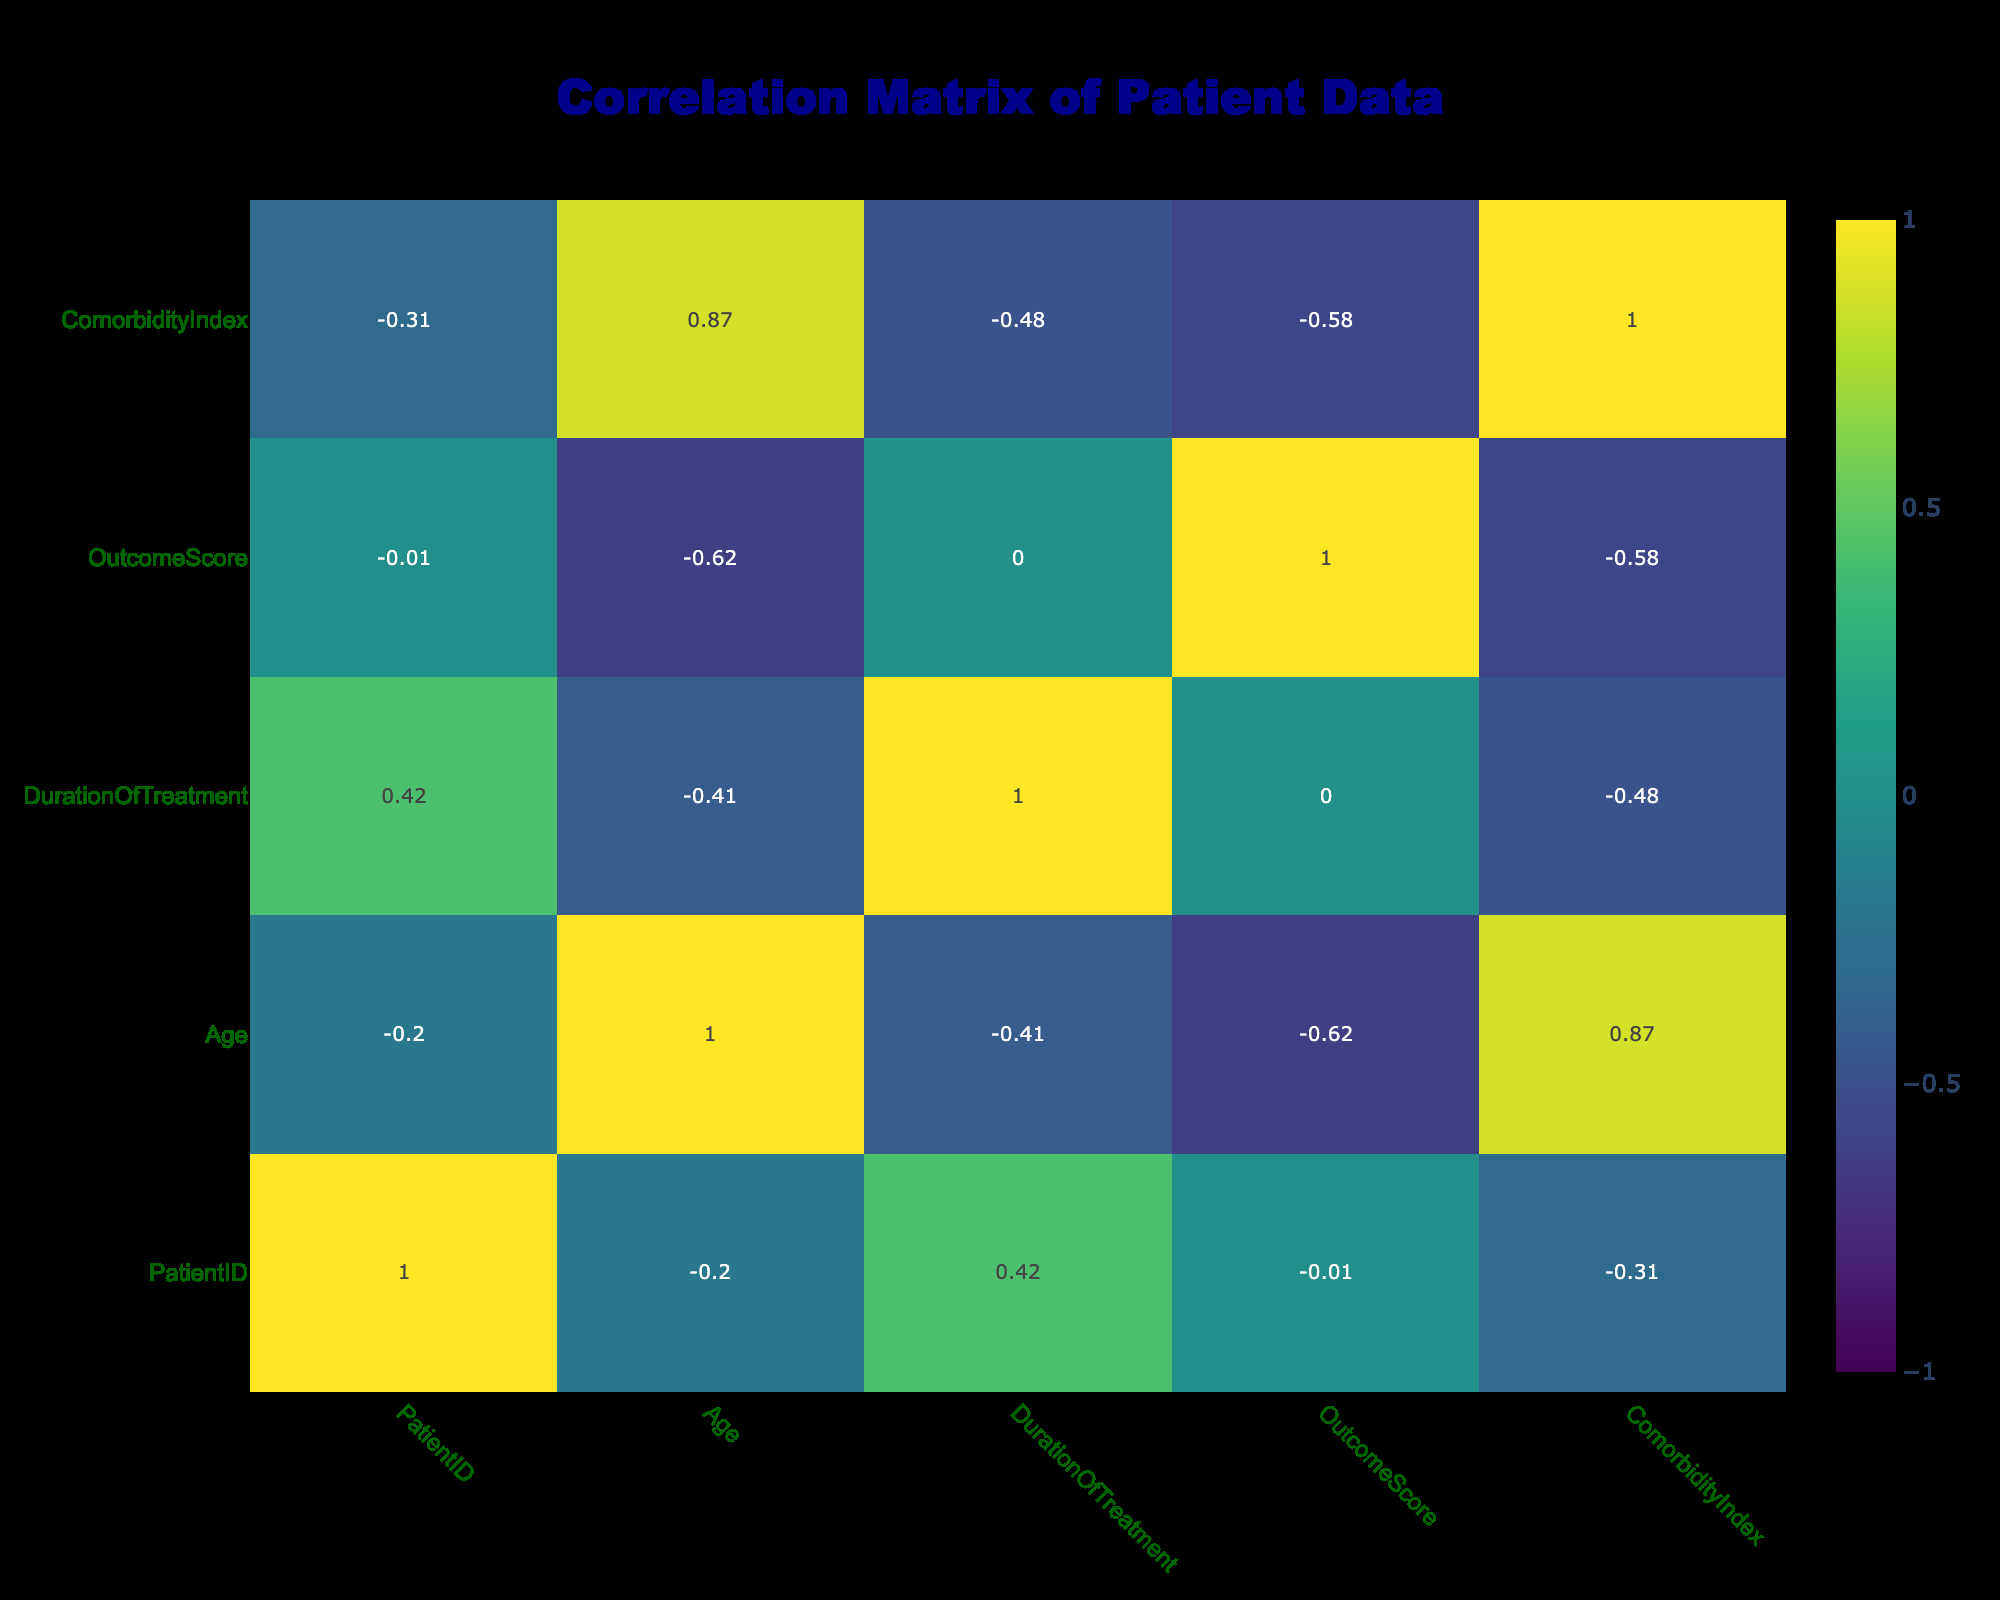What is the correlation between Outcome Score and Duration of Treatment? The correlation value between Outcome Score and Duration of Treatment can be directly observed in the correlation matrix at the intersecting row and column. This value indicates how strongly these two variables are related.
Answer: The correlation is approximately 0.15 Is there a higher average Outcome Score for patients who underwent Surgery compared to those who received Radiation treatment? To find the average Outcome Score, we first identify the Outcome Scores for both Surgery (95, 90, 93) and Radiation (75, 70, 80). Calculating these gives us 92.67 for Surgery and 75 for Radiation. Comparing these averages shows that Surgery has a higher Outcome Score.
Answer: Yes What is the average Comorbidity Index for all female patients? The Comorbidity Index values for female patients are found in the data (3, 4, 5). Summing these gives 12, and dividing by the total female patients (3) yields an average of 4.
Answer: The average is 4 Is there a correlation of 1 between Treatment Type and Outcome Score? Correlation of 1 indicates a perfect positive relationship. Observing the correlation matrix will show that the correlation between Treatment Type (categorical) and Outcome Score does not reach 1, as treatment types vary and do not dictate outcome scores perfectly.
Answer: No What is the difference in average Outcome Scores between male and female patients? To find the average for males (85, 90, 88, 92, 87), we add these scores to get 442 and divide by 5, resulting in 88.4 for males. For females (95, 75, 70, 93), summing gives 333 with a division by 4 yielding 83.25 for females. The difference is 88.4 - 83.25 = 5.15.
Answer: The difference is 5.15 